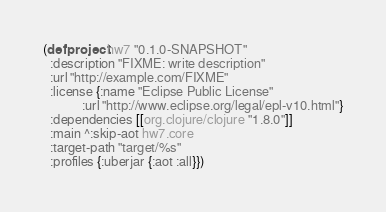<code> <loc_0><loc_0><loc_500><loc_500><_Clojure_>(defproject hw7 "0.1.0-SNAPSHOT"
  :description "FIXME: write description"
  :url "http://example.com/FIXME"
  :license {:name "Eclipse Public License"
            :url "http://www.eclipse.org/legal/epl-v10.html"}
  :dependencies [[org.clojure/clojure "1.8.0"]]
  :main ^:skip-aot hw7.core
  :target-path "target/%s"
  :profiles {:uberjar {:aot :all}})
</code> 